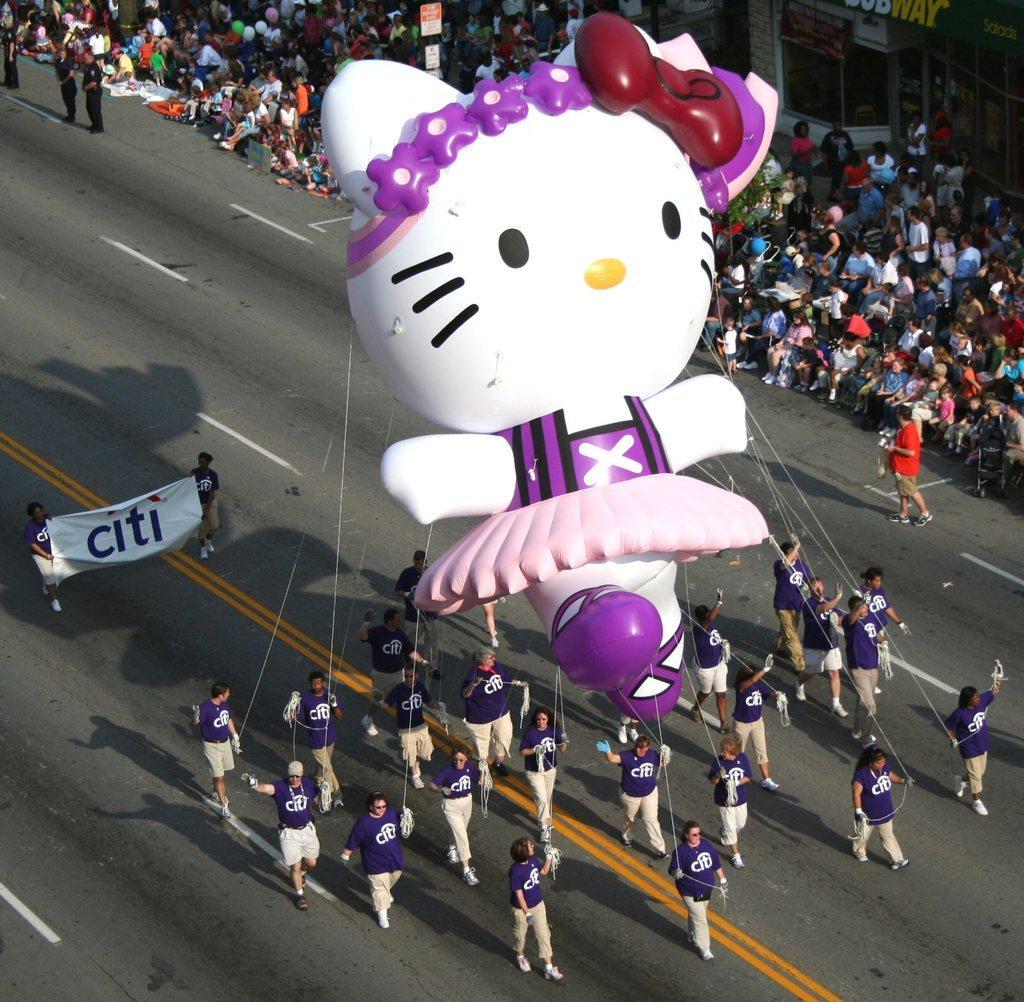Describe this image in one or two sentences. In this image there are group of people walking, and they are holding some ropes and in the air there is an air balloon. In the background there are some persons who are holding some boards and walking, on the right side there are a group of people who are sitting and watching them. At the bottom there is road. 